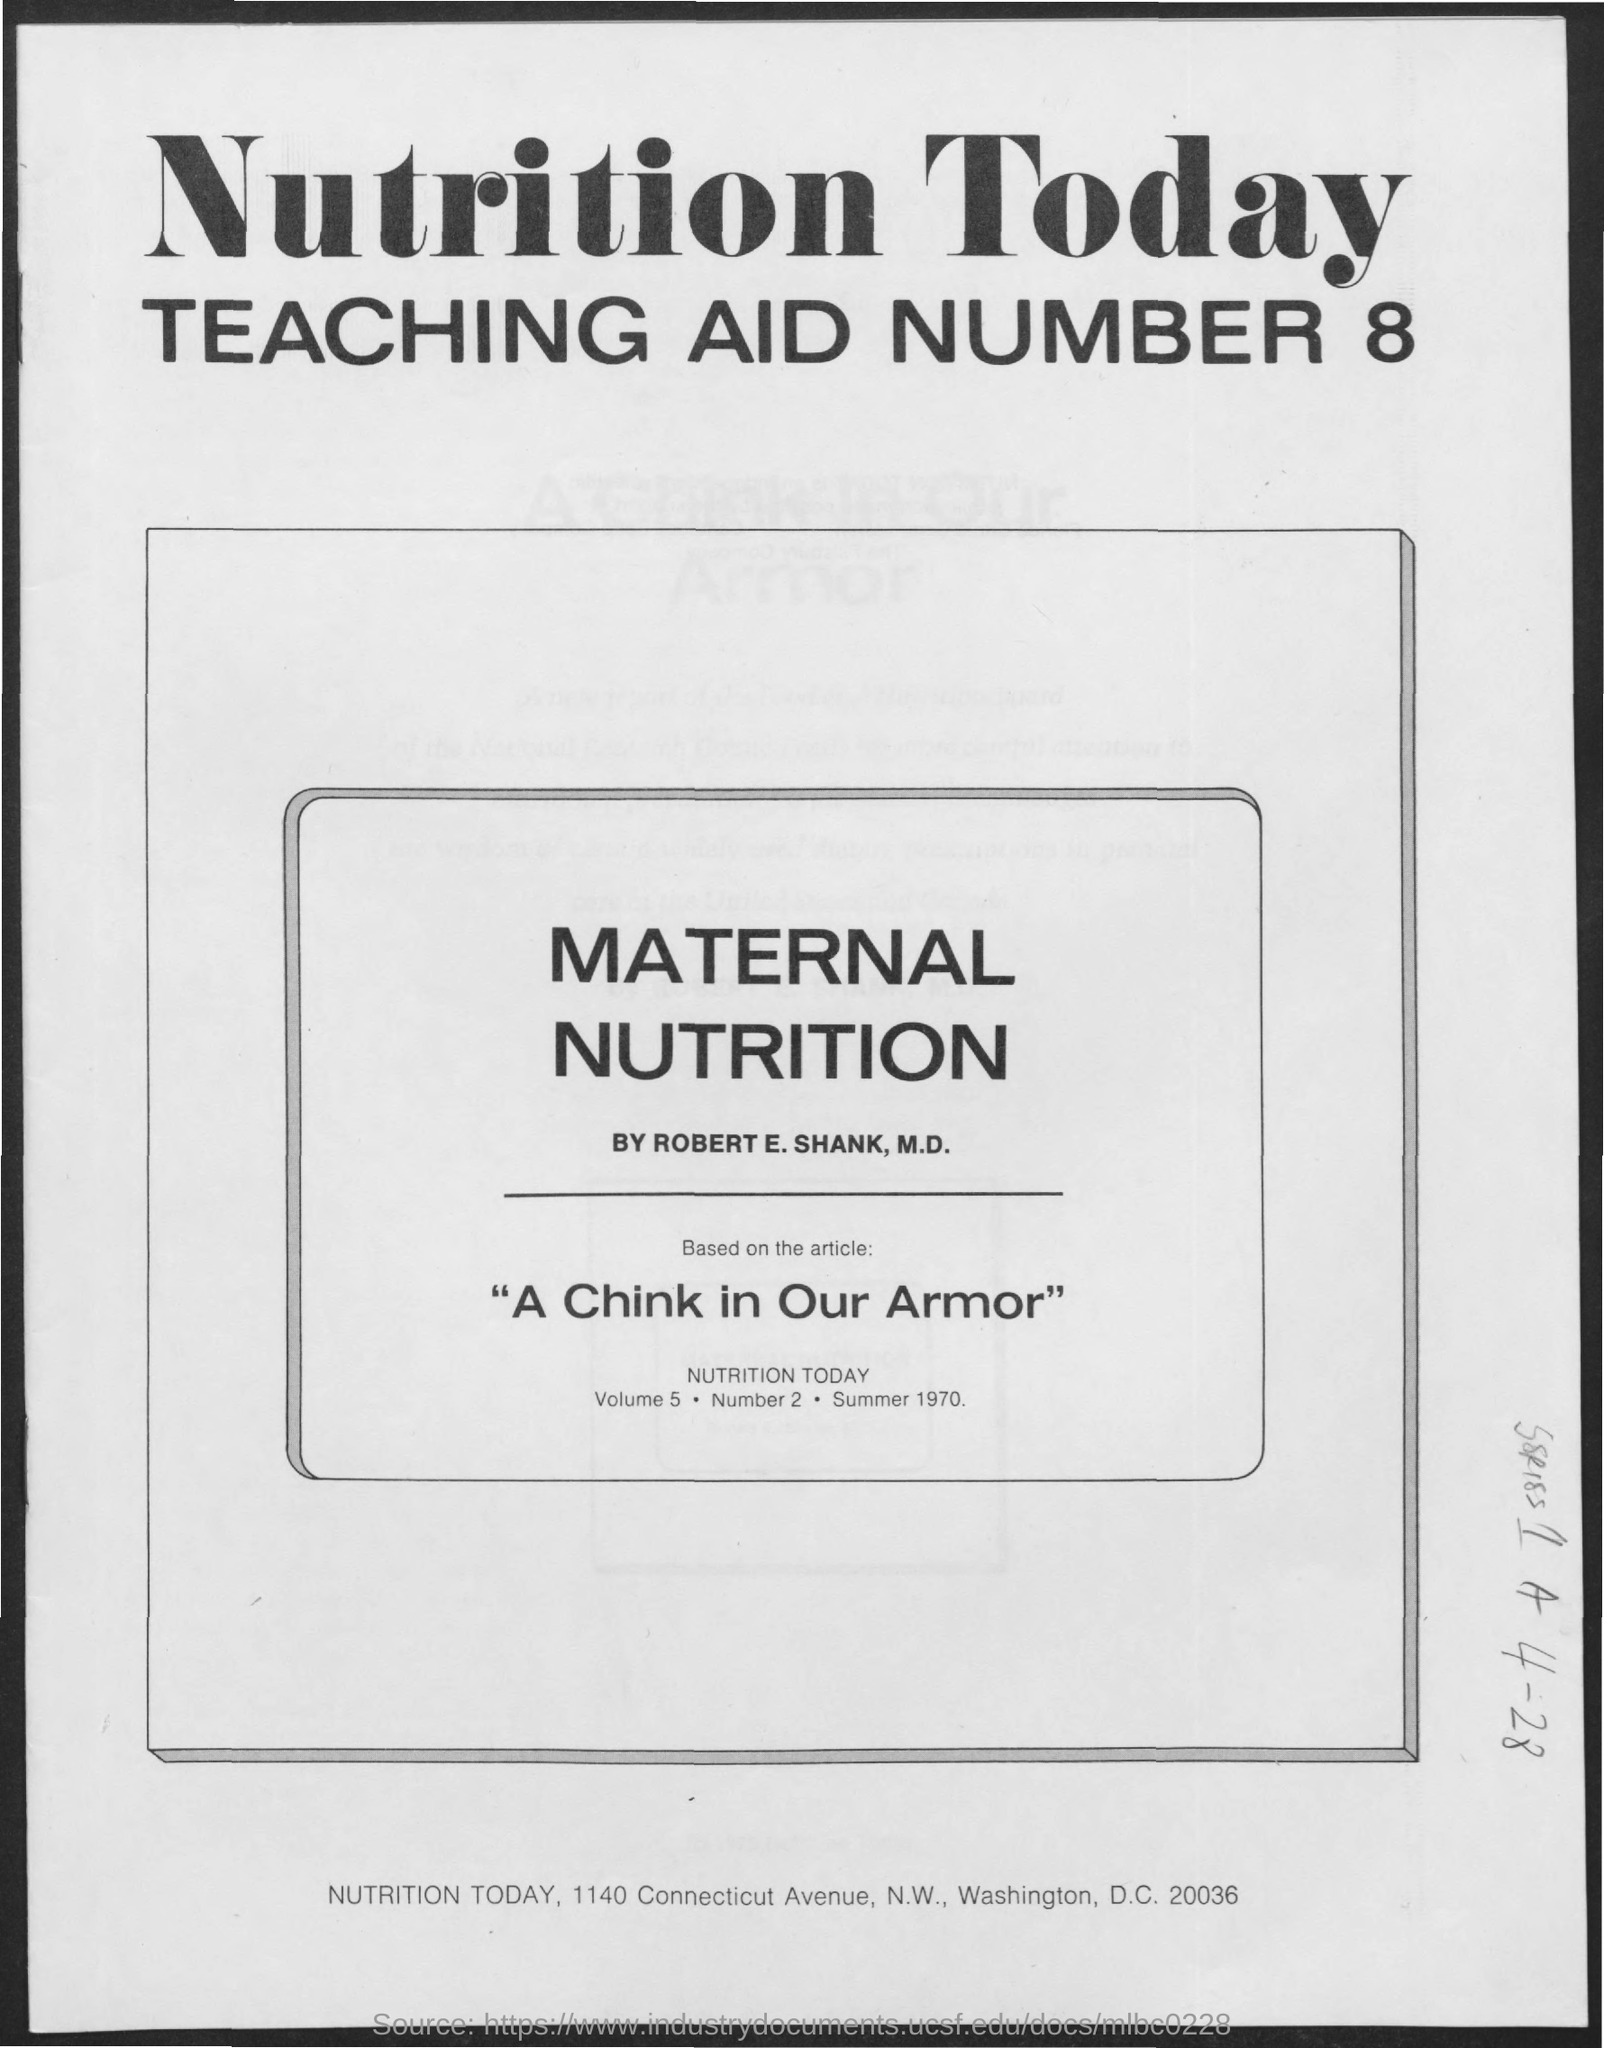List a handful of essential elements in this visual. The article is written by Robert E. Shank, M.D. 